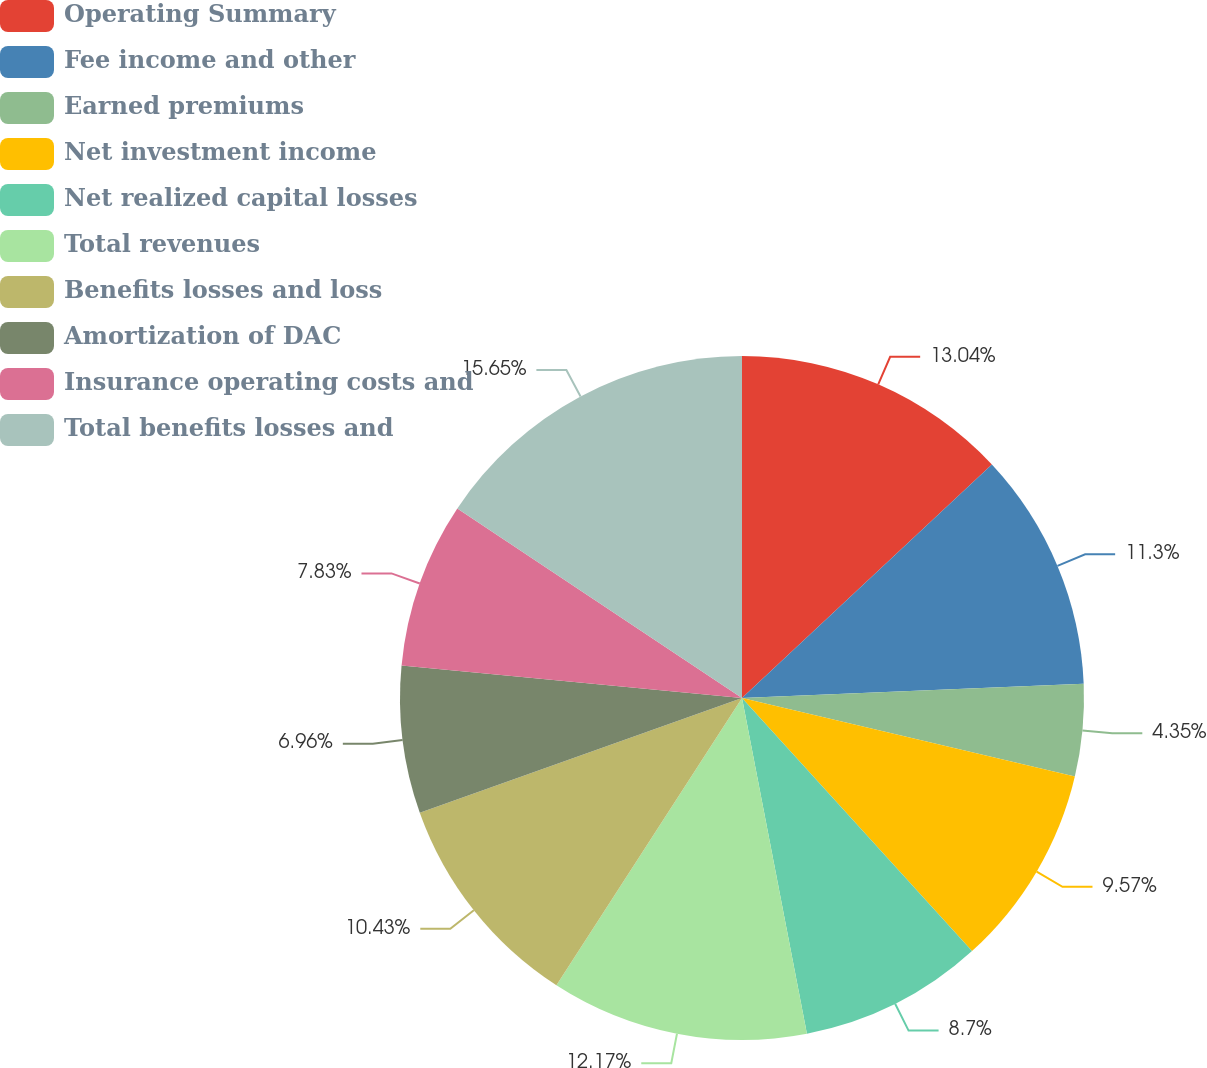<chart> <loc_0><loc_0><loc_500><loc_500><pie_chart><fcel>Operating Summary<fcel>Fee income and other<fcel>Earned premiums<fcel>Net investment income<fcel>Net realized capital losses<fcel>Total revenues<fcel>Benefits losses and loss<fcel>Amortization of DAC<fcel>Insurance operating costs and<fcel>Total benefits losses and<nl><fcel>13.04%<fcel>11.3%<fcel>4.35%<fcel>9.57%<fcel>8.7%<fcel>12.17%<fcel>10.43%<fcel>6.96%<fcel>7.83%<fcel>15.65%<nl></chart> 